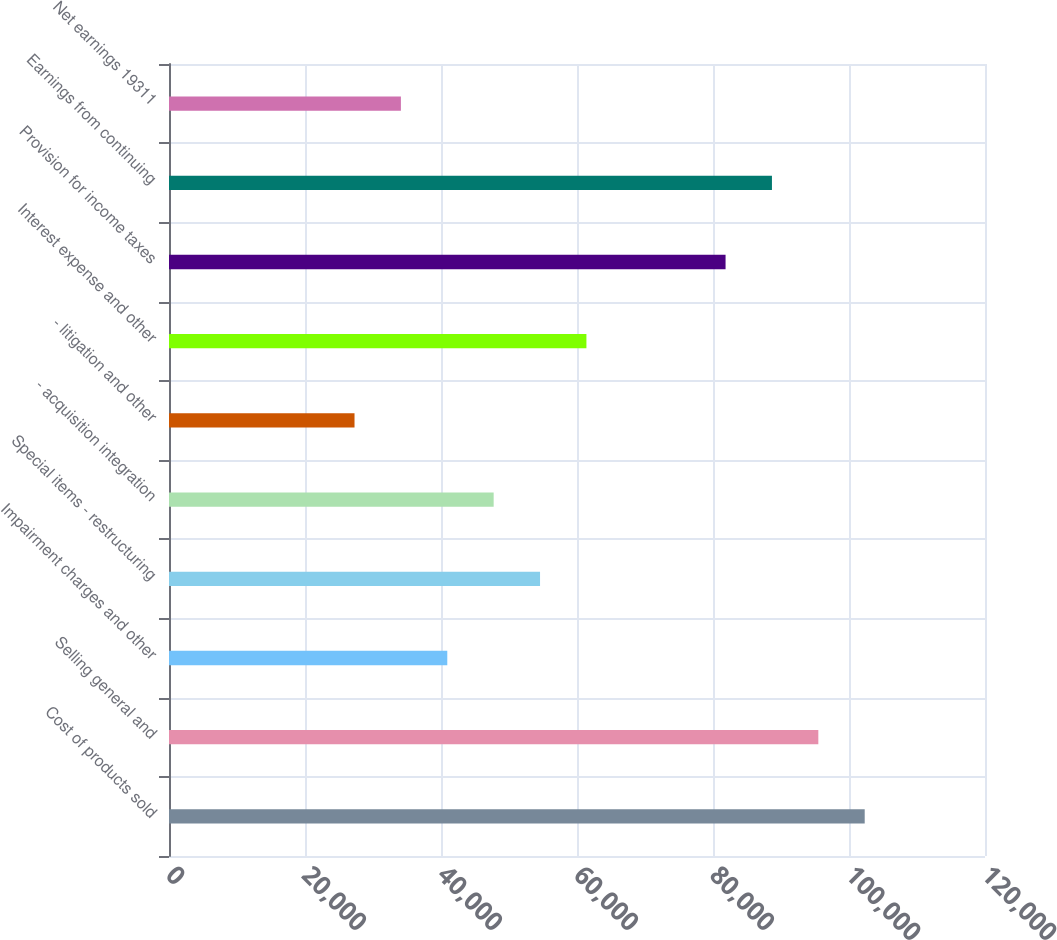<chart> <loc_0><loc_0><loc_500><loc_500><bar_chart><fcel>Cost of products sold<fcel>Selling general and<fcel>Impairment charges and other<fcel>Special items - restructuring<fcel>- acquisition integration<fcel>- litigation and other<fcel>Interest expense and other<fcel>Provision for income taxes<fcel>Earnings from continuing<fcel>Net earnings 19311<nl><fcel>102309<fcel>95488.9<fcel>40923.8<fcel>54565.1<fcel>47744.4<fcel>27282.6<fcel>61385.7<fcel>81847.6<fcel>88668.2<fcel>34103.2<nl></chart> 